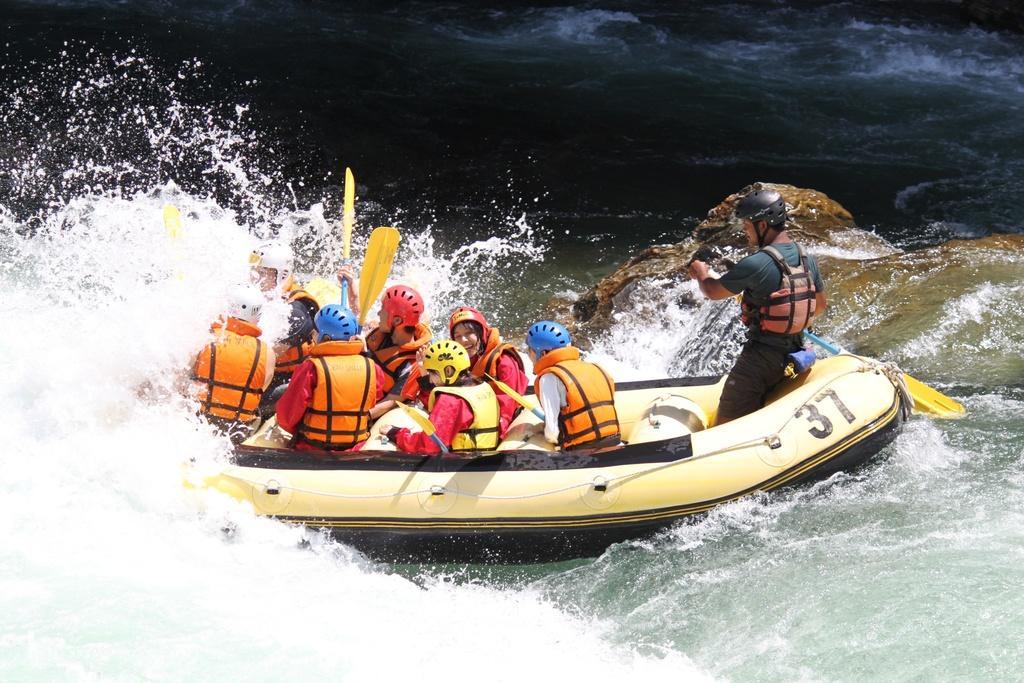In one or two sentences, can you explain what this image depicts? In this image there are persons rafting in water. 